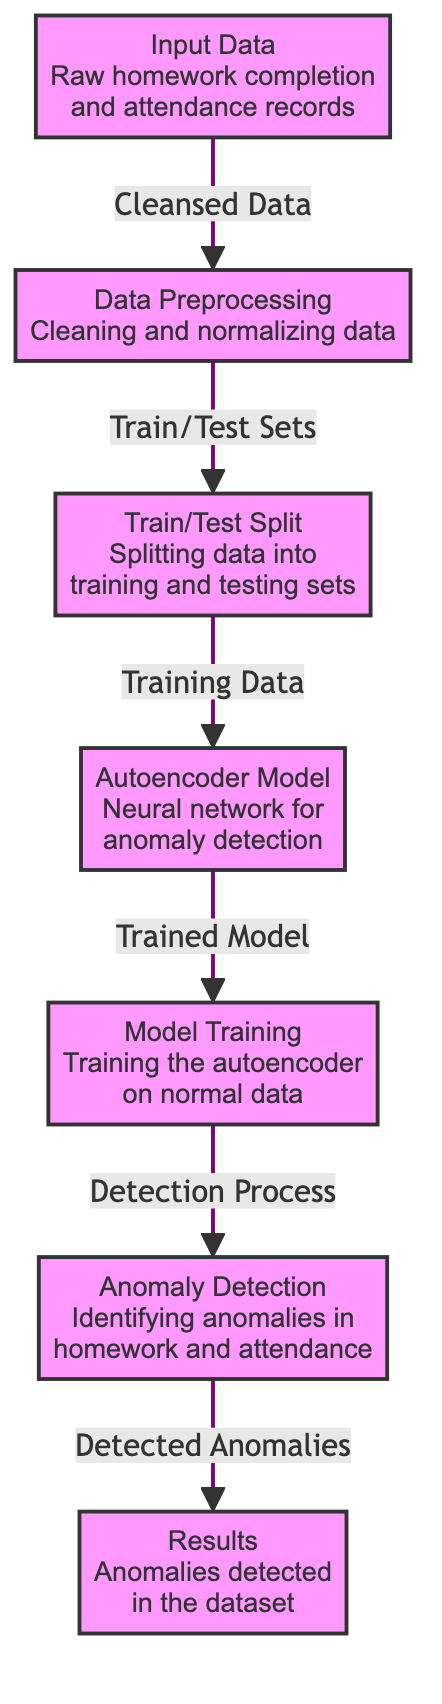What is the first step in the diagram? The first step shown in the diagram is "Input Data", which consists of raw homework completion and attendance records. This is the initial stage of processing before any manipulations are done.
Answer: Input Data How many nodes are present in the diagram? The diagram has a total of seven nodes, each representing a different step in the process of anomaly detection using autoencoders. This can be counted directly from the visual representation.
Answer: Seven What type of model is used in this process? The model type specified in the diagram is an "Autoencoder". This indicates that the neural network utilized for anomaly detection follows the structure and function of autoencoders in machine learning.
Answer: Autoencoder What is the output of the anomaly detection step? The output from the anomaly detection step is "Detected Anomalies", which indicates the results observed after applying the autoencoder model to identify anomalies within the dataset.
Answer: Detected Anomalies In which step is the data split? Data splitting occurs in the "Train/Test Split" step. This is where the original dataset is divided into training and testing sets to facilitate model training and evaluation.
Answer: Train/Test Split What is the primary function of the "Data Preprocessing" node? The primary function of the "Data Preprocessing" node is "Cleaning and normalizing data". This step prepares the input data for subsequent analysis by ensuring it is usable and standardized.
Answer: Cleaning and normalizing data Which node follows the "Model Training" step? The node that follows the "Model Training" step is "Anomaly Detection". After training the model, the next logical action is to apply it to the data and identify any anomalies present.
Answer: Anomaly Detection What type of results are produced in the last step? The results produced in the last step are related to the "Anomalies detected in the dataset". This indicates that the process effectively identifies unusual patterns in homework and attendance data.
Answer: Anomalies detected in the dataset What is the function of the "Autoencoder Model" node? The function of the "Autoencoder Model" node is "Neural network for anomaly detection". This highlights that the model's purpose is to detect anomalies within the input data specifically using an autoencoder architecture.
Answer: Neural network for anomaly detection 